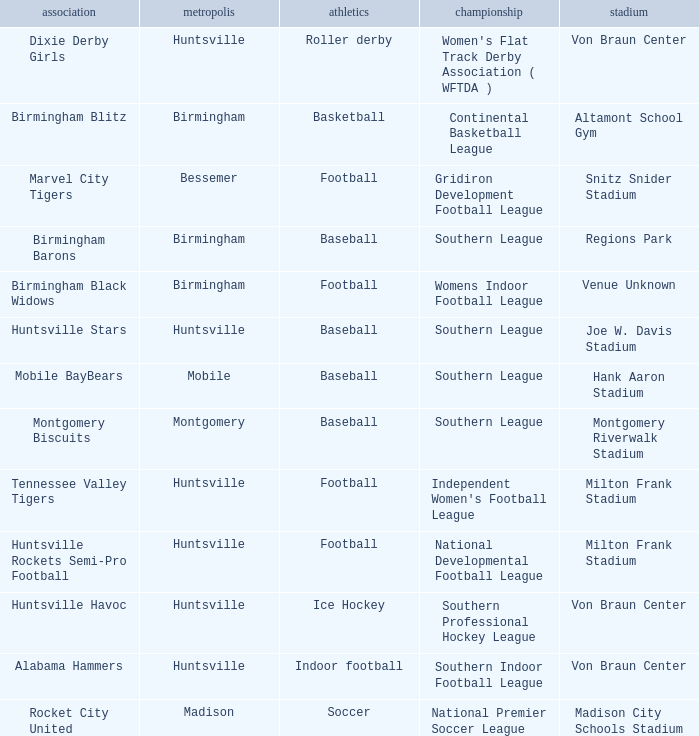Which venue hosted the Gridiron Development Football League? Snitz Snider Stadium. 